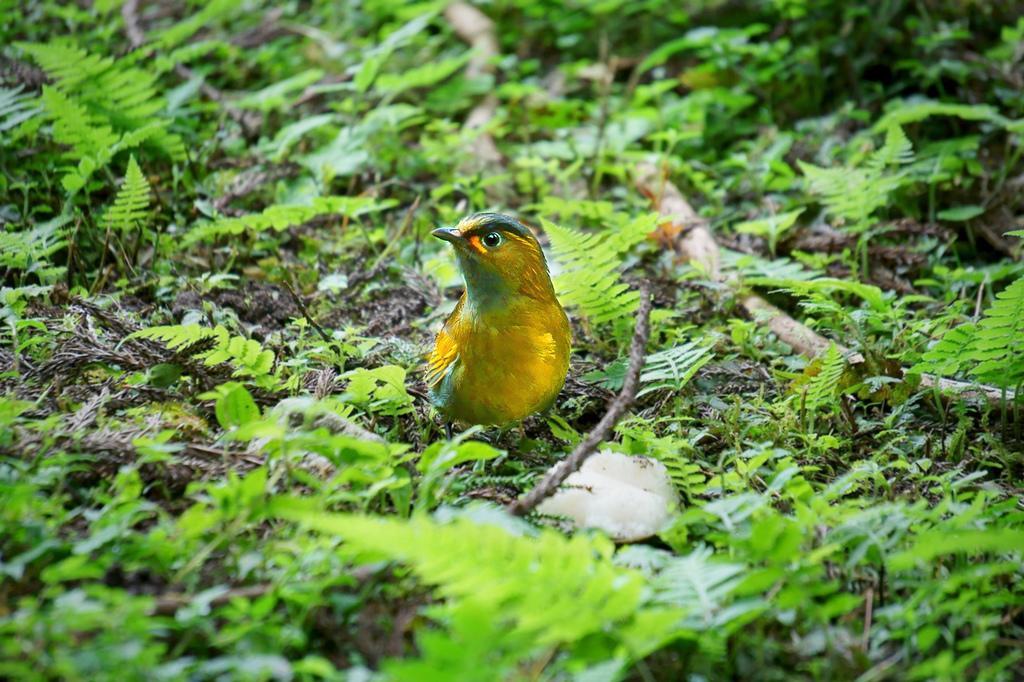Can you describe this image briefly? In this image there is a bird on the ground. on the ground there are plants. 